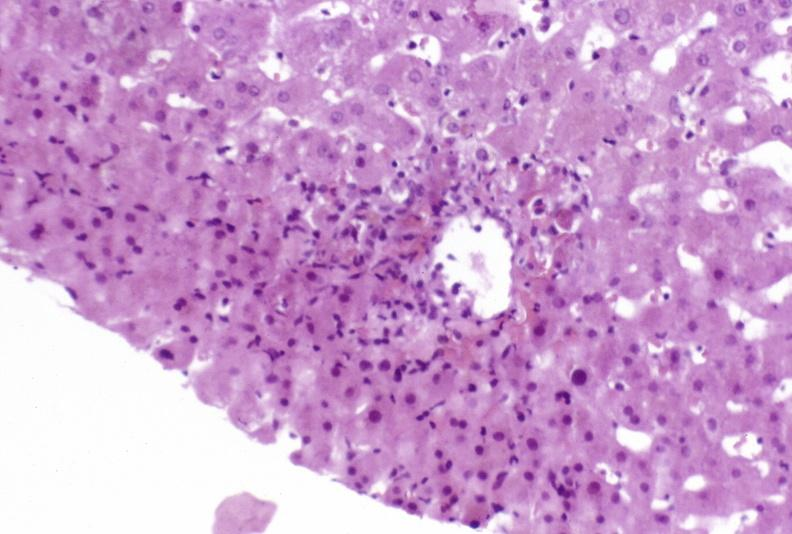s hepatobiliary present?
Answer the question using a single word or phrase. Yes 